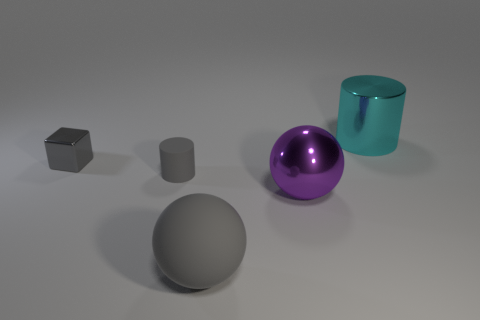Add 1 tiny gray metallic blocks. How many objects exist? 6 Subtract all gray balls. How many balls are left? 1 Subtract all blocks. How many objects are left? 4 Subtract all brown balls. How many red cylinders are left? 0 Subtract all gray objects. Subtract all gray rubber objects. How many objects are left? 0 Add 5 gray metallic cubes. How many gray metallic cubes are left? 6 Add 4 purple shiny objects. How many purple shiny objects exist? 5 Subtract 0 cyan balls. How many objects are left? 5 Subtract 1 cylinders. How many cylinders are left? 1 Subtract all purple balls. Subtract all purple cubes. How many balls are left? 1 